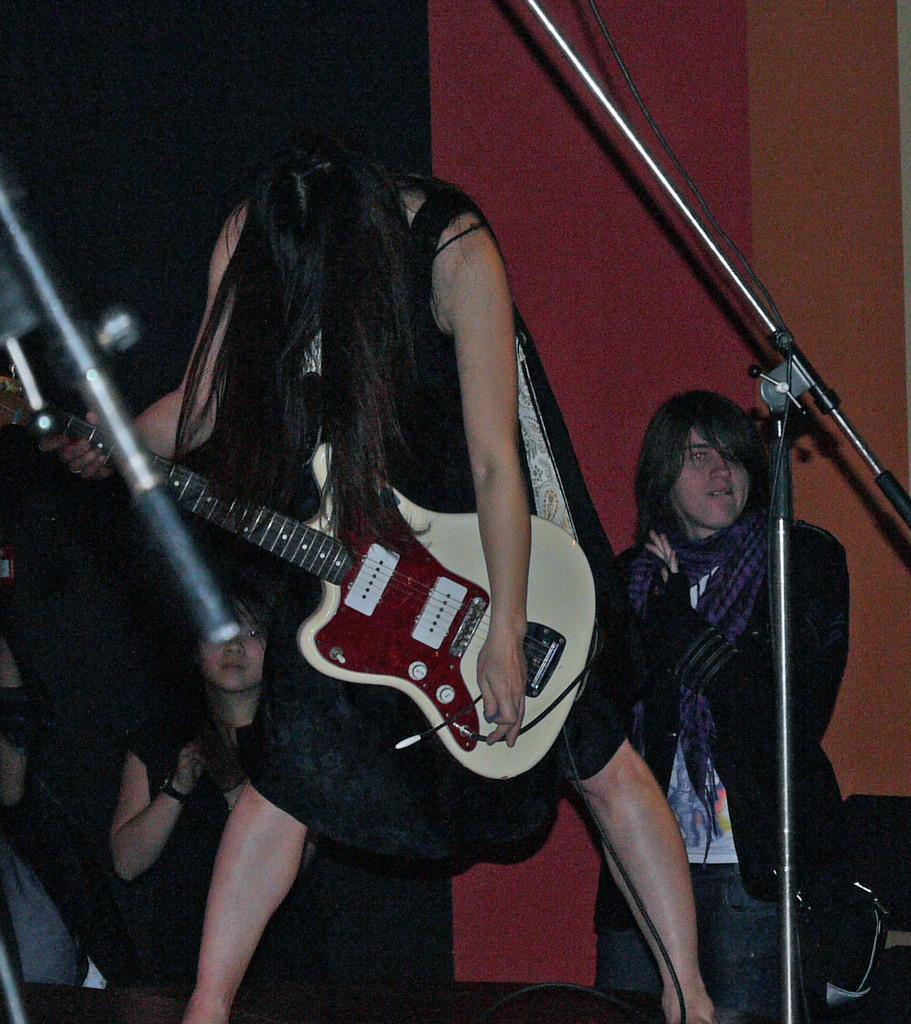What is the woman in the image doing? The woman in the image is playing a guitar. Can you describe the other person in the image? There is another woman standing behind her. What type of clover is the woman reading in the image? There is no clover or reading material present in the image; the woman is playing a guitar, and there is another woman standing behind her. 